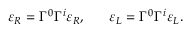<formula> <loc_0><loc_0><loc_500><loc_500>\varepsilon _ { R } = \Gamma ^ { 0 } \Gamma ^ { i } \varepsilon _ { R } , \quad \ \varepsilon _ { L } = \Gamma ^ { 0 } \Gamma ^ { i } \varepsilon _ { L } .</formula> 